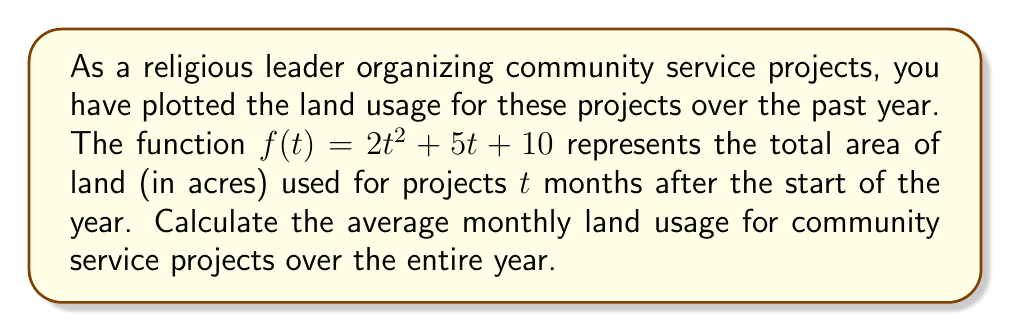Show me your answer to this math problem. To solve this problem, we need to follow these steps:

1) First, we need to find the total area of land used over the year. This can be done by integrating the given function from $t=0$ to $t=12$ (as there are 12 months in a year).

2) The definite integral will give us the area under the curve, which represents the total accumulated land usage over the year.

3) To find the average monthly usage, we'll divide the total by 12.

Let's proceed step by step:

1) The definite integral we need to evaluate is:

   $$\int_0^{12} (2t^2 + 5t + 10) dt$$

2) Let's integrate this function:

   $$\left[\frac{2t^3}{3} + \frac{5t^2}{2} + 10t\right]_0^{12}$$

3) Now, let's evaluate this from 0 to 12:

   $$\left(\frac{2(12^3)}{3} + \frac{5(12^2)}{2} + 10(12)\right) - \left(\frac{2(0^3)}{3} + \frac{5(0^2)}{2} + 10(0)\right)$$

4) Simplify:

   $$\left(\frac{2(1728)}{3} + \frac{5(144)}{2} + 120\right) - 0$$
   
   $$= 1152 + 360 + 120 = 1632$$

5) So, the total land usage over the year is 1632 acres.

6) To find the average monthly usage, we divide by 12:

   $$\frac{1632}{12} = 136$$

Therefore, the average monthly land usage for community service projects is 136 acres.
Answer: 136 acres 